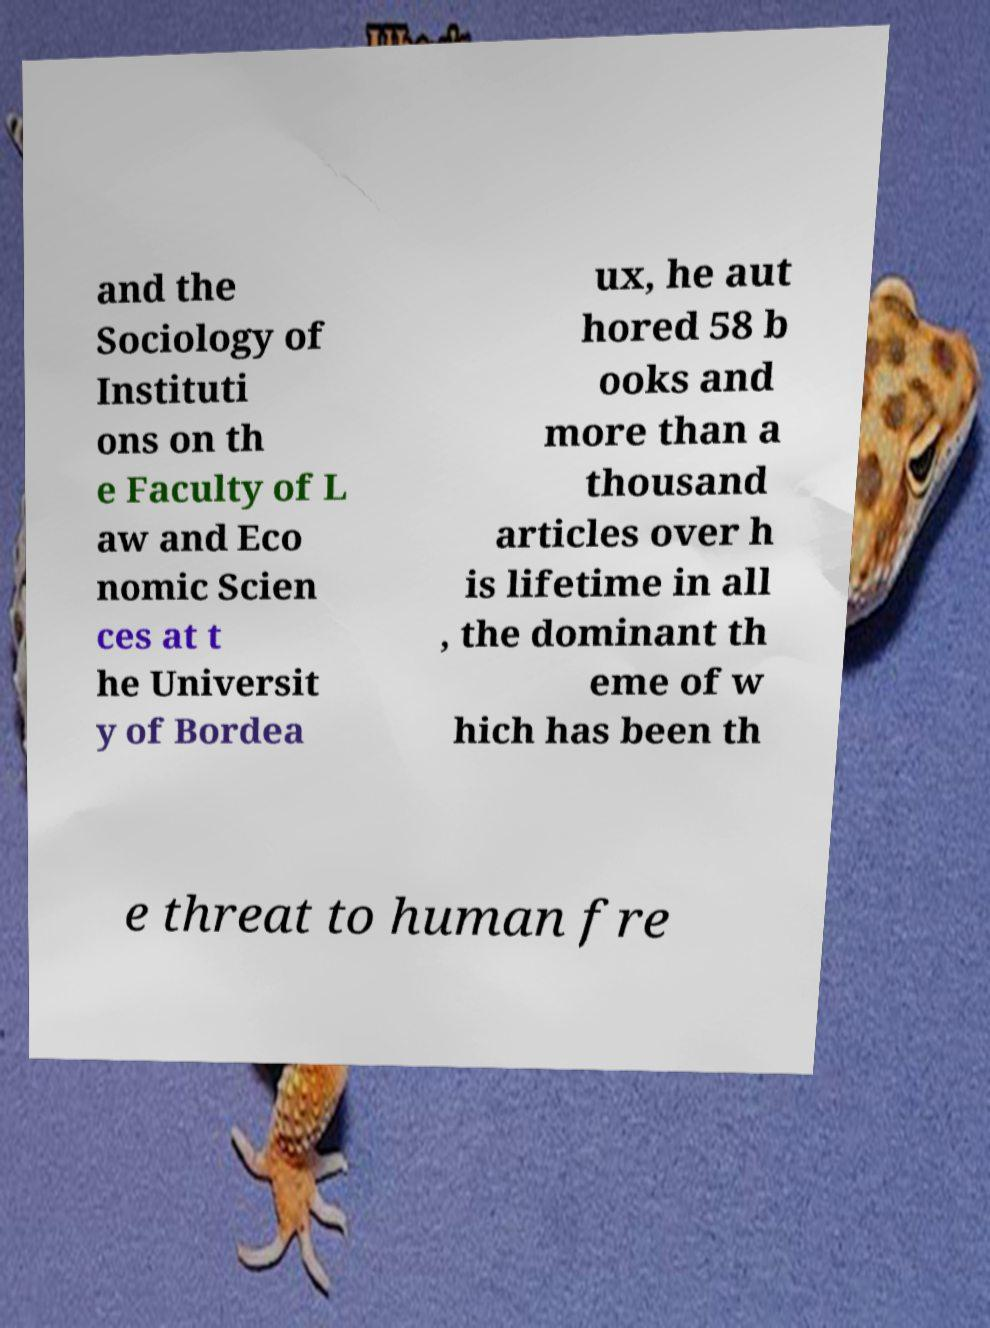Can you accurately transcribe the text from the provided image for me? and the Sociology of Instituti ons on th e Faculty of L aw and Eco nomic Scien ces at t he Universit y of Bordea ux, he aut hored 58 b ooks and more than a thousand articles over h is lifetime in all , the dominant th eme of w hich has been th e threat to human fre 